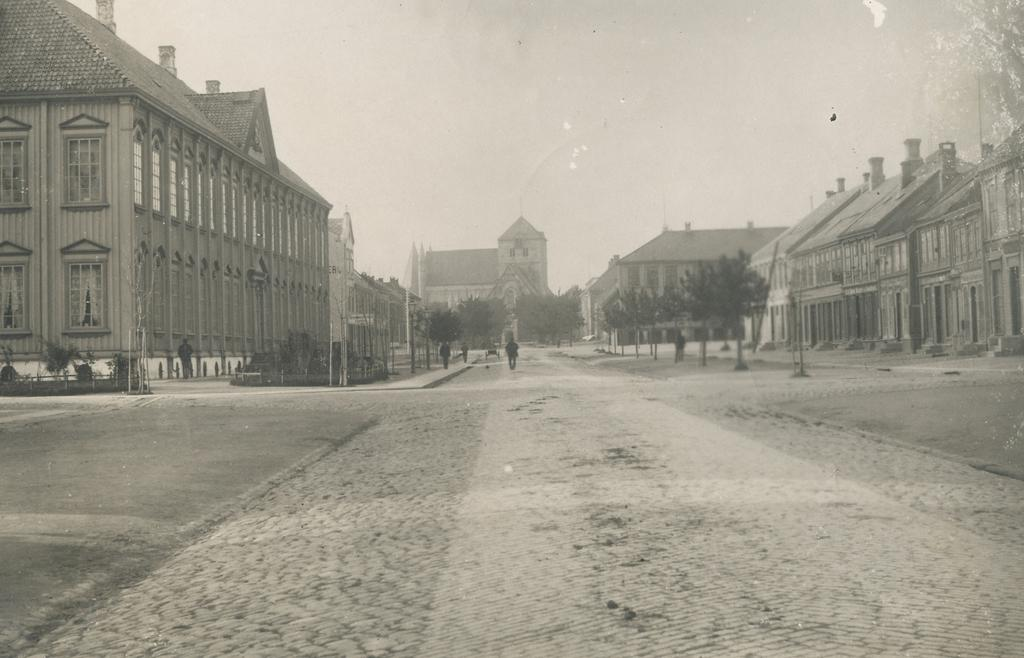What is the color scheme of the image? The image is black and white. What type of scene is depicted in the image? The image shows an outside view. What structures can be seen in the image? There are buildings in the image. What type of vegetation is present in the image? There are trees in the image. What is visible at the top of the image? The sky is visible at the top of the image. How many dogs are visible in the image? There are no dogs present in the image. What level of expertise is required to understand the image? The image does not require any specific level of expertise to understand; it is a straightforward black and white image of an outside view with buildings, trees, and the sky. 